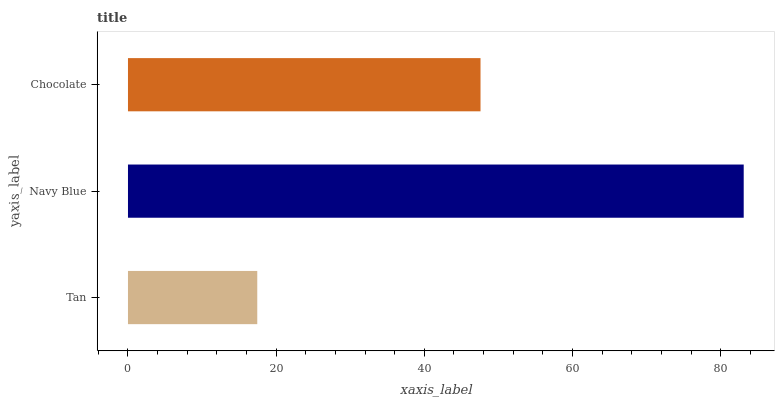Is Tan the minimum?
Answer yes or no. Yes. Is Navy Blue the maximum?
Answer yes or no. Yes. Is Chocolate the minimum?
Answer yes or no. No. Is Chocolate the maximum?
Answer yes or no. No. Is Navy Blue greater than Chocolate?
Answer yes or no. Yes. Is Chocolate less than Navy Blue?
Answer yes or no. Yes. Is Chocolate greater than Navy Blue?
Answer yes or no. No. Is Navy Blue less than Chocolate?
Answer yes or no. No. Is Chocolate the high median?
Answer yes or no. Yes. Is Chocolate the low median?
Answer yes or no. Yes. Is Tan the high median?
Answer yes or no. No. Is Navy Blue the low median?
Answer yes or no. No. 